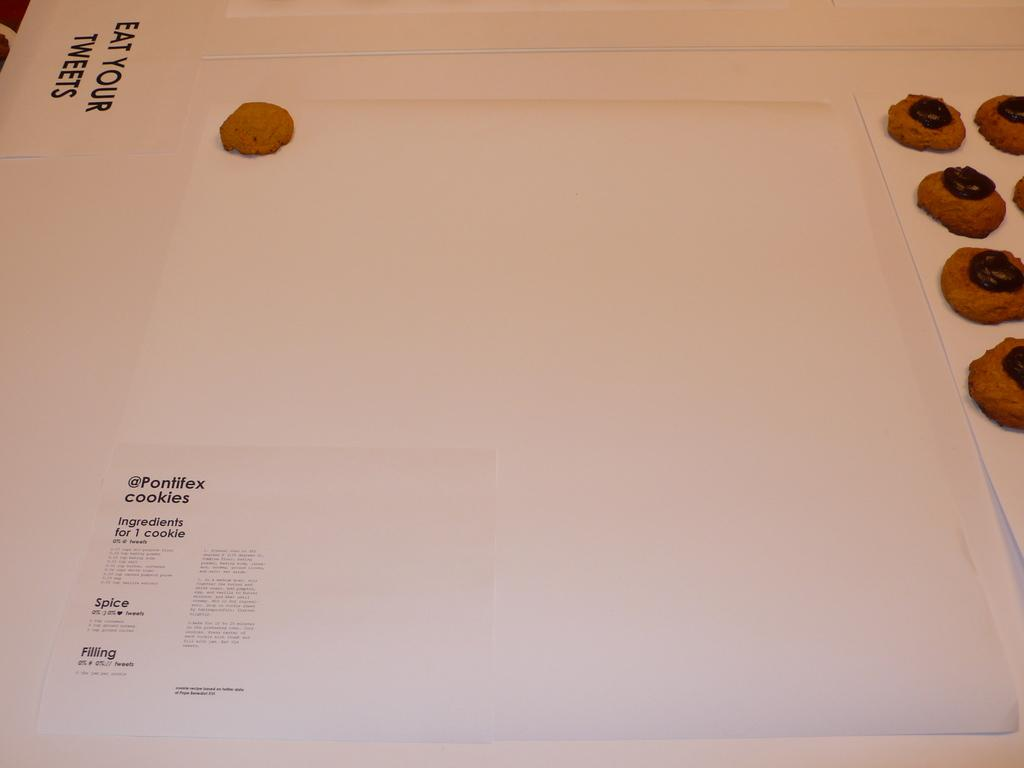What type of food is visible in the image? There are cookies in the image. What is the specific feature of these cookies? The cookies have chocolate cream on them. On what surface are the cookies placed? The cookies are on papers. Where are the cookies located in the image? The cookies are on a whiteboard. What type of animal is sitting on the cookies in the image? There is no animal present in the image; it only features cookies on a whiteboard. 